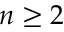Convert formula to latex. <formula><loc_0><loc_0><loc_500><loc_500>n \geq 2</formula> 